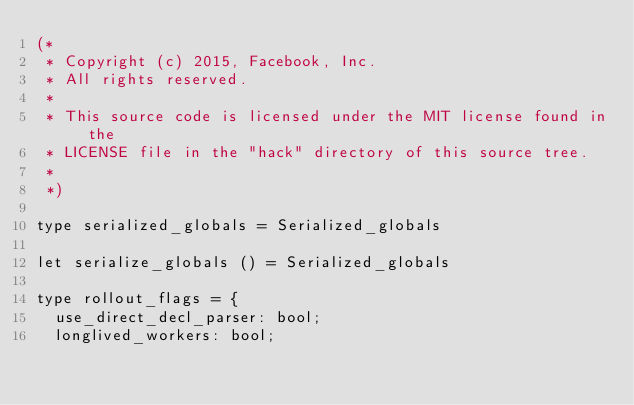<code> <loc_0><loc_0><loc_500><loc_500><_OCaml_>(*
 * Copyright (c) 2015, Facebook, Inc.
 * All rights reserved.
 *
 * This source code is licensed under the MIT license found in the
 * LICENSE file in the "hack" directory of this source tree.
 *
 *)

type serialized_globals = Serialized_globals

let serialize_globals () = Serialized_globals

type rollout_flags = {
  use_direct_decl_parser: bool;
  longlived_workers: bool;</code> 